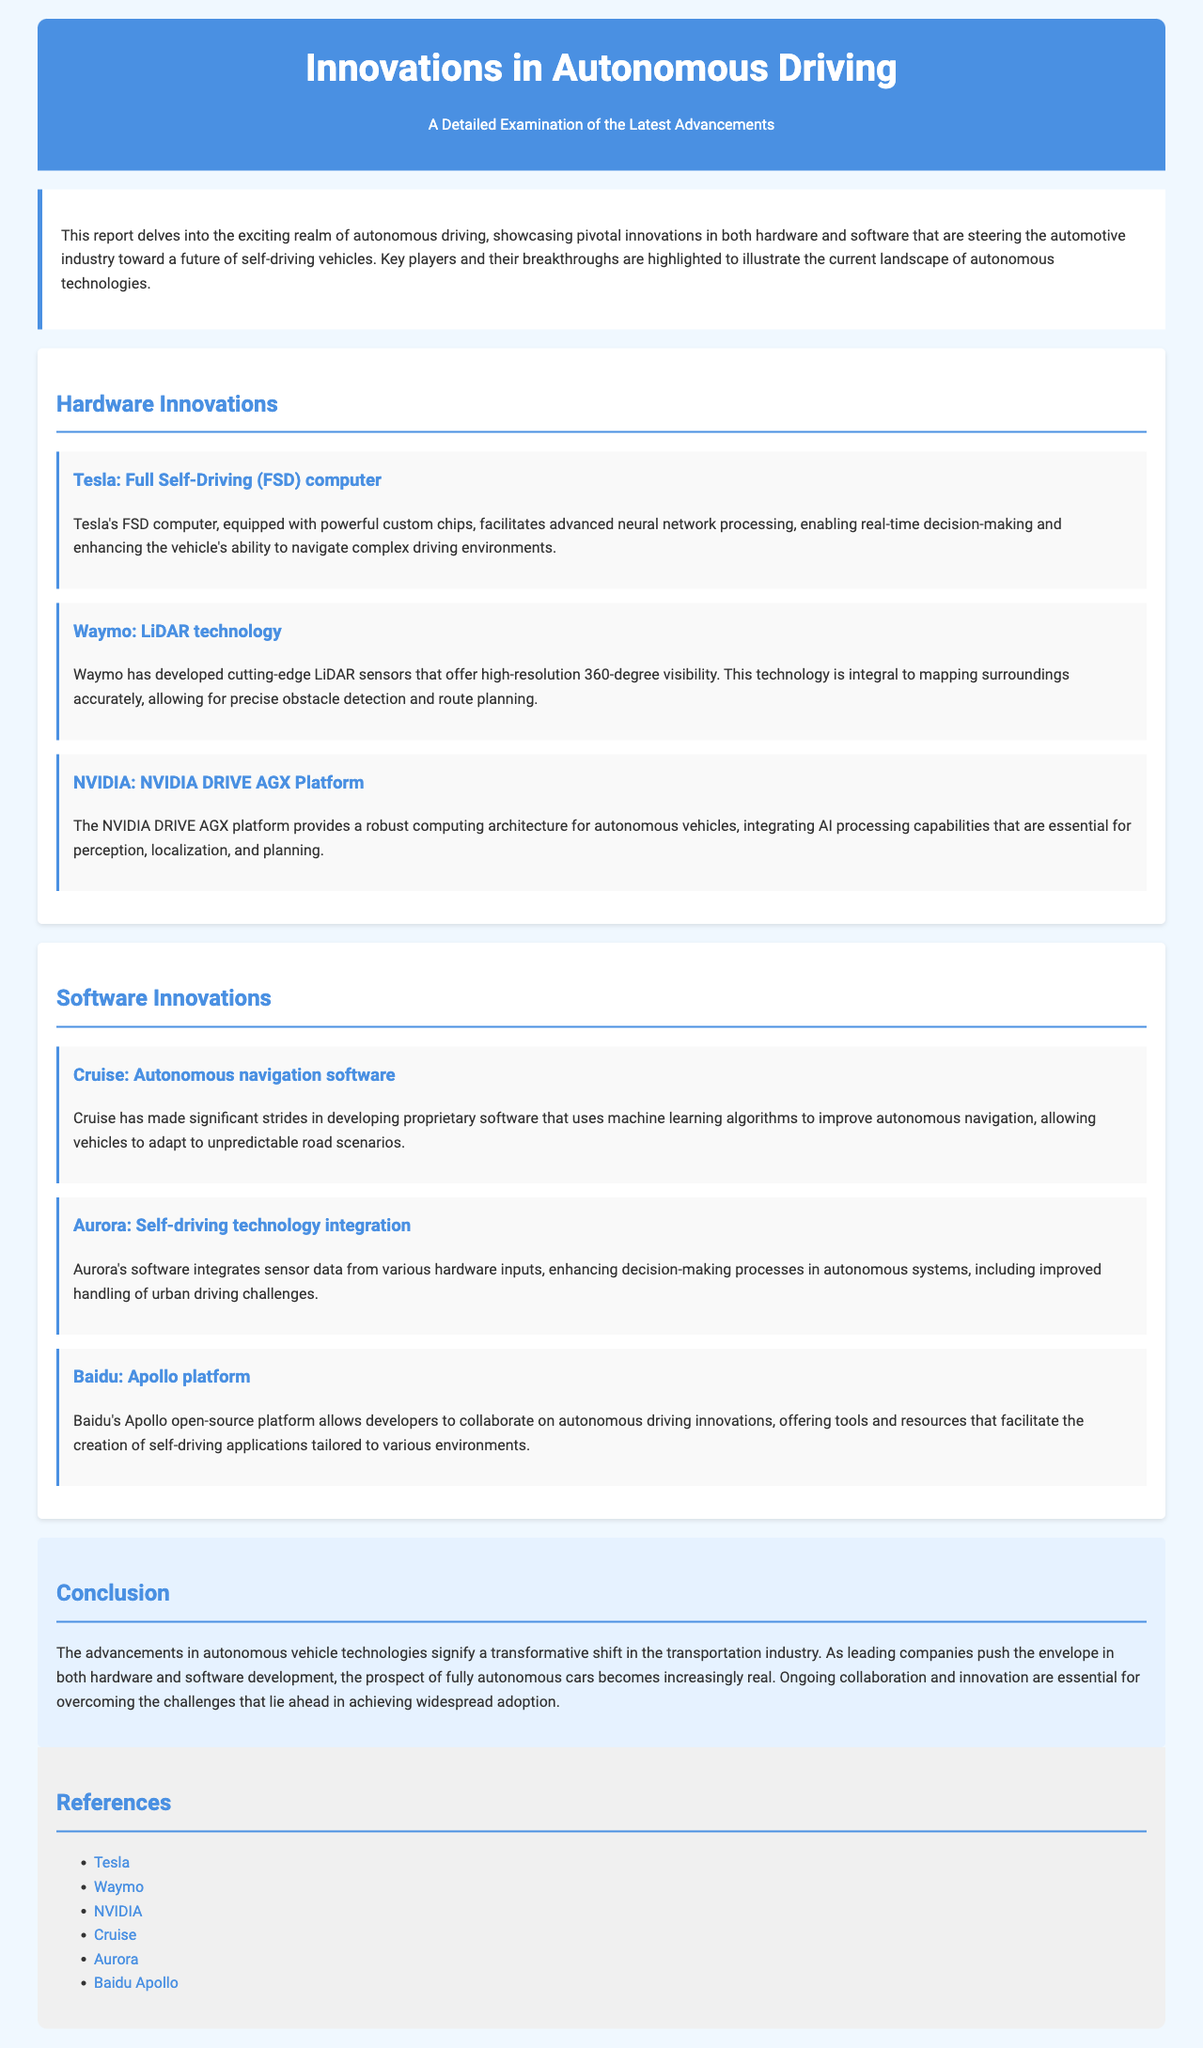What is the main focus of the report? The main focus of the report is to examine the latest advancements in autonomous vehicle technologies highlighting key companies and their breakthroughs in hardware and software development.
Answer: Advancements in autonomous vehicle technologies Who developed the Full Self-Driving computer? The document mentions Tesla as the creator of the Full Self-Driving computer.
Answer: Tesla What technology does Waymo specialize in? Waymo is known for its development of advanced LiDAR technology.
Answer: LiDAR technology Which platform does Baidu offer for autonomous driving innovation? The report states that Baidu provides the Apollo platform for autonomous driving applications.
Answer: Apollo platform What important capability does the NVIDIA DRIVE AGX platform integrate? The NVIDIA DRIVE AGX platform integrates AI processing capabilities essential for perception, localization, and planning in autonomous vehicles.
Answer: AI processing capabilities Which company focuses on integrating sensor data for decision-making processes? The company that focuses on integrating sensor data for decision-making is Aurora.
Answer: Aurora What does Cruise develop to enhance navigation? Cruise develops autonomous navigation software that utilizes machine learning algorithms.
Answer: Autonomous navigation software What is emphasized as essential for achieving widespread adoption of autonomous vehicles? The report emphasizes that ongoing collaboration and innovation are essential for achieving widespread adoption.
Answer: Collaboration and innovation 